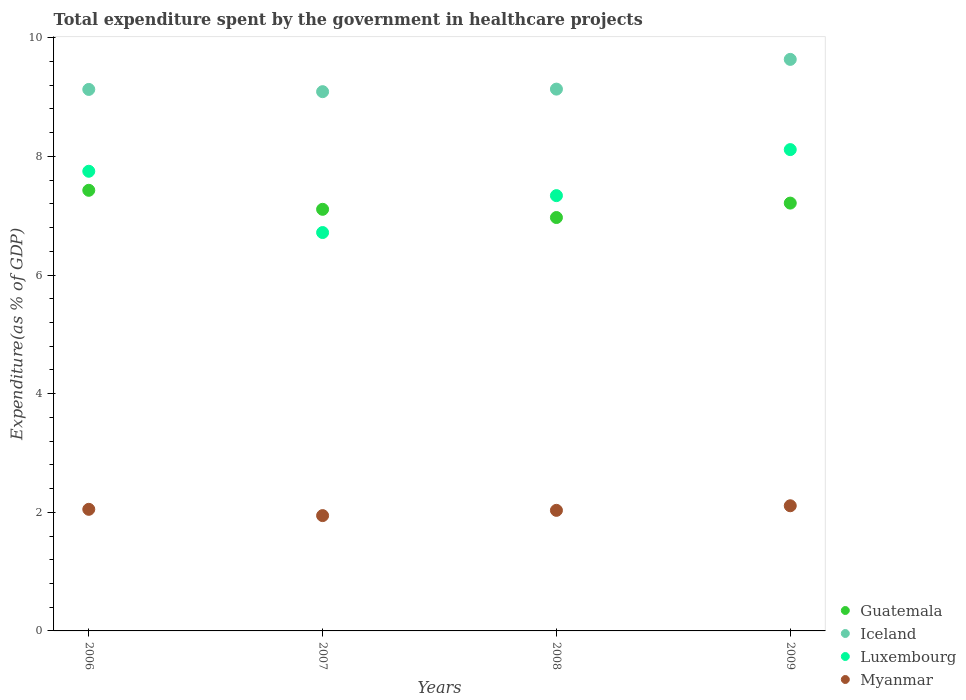Is the number of dotlines equal to the number of legend labels?
Ensure brevity in your answer.  Yes. What is the total expenditure spent by the government in healthcare projects in Iceland in 2007?
Ensure brevity in your answer.  9.09. Across all years, what is the maximum total expenditure spent by the government in healthcare projects in Guatemala?
Provide a short and direct response. 7.43. Across all years, what is the minimum total expenditure spent by the government in healthcare projects in Myanmar?
Give a very brief answer. 1.94. In which year was the total expenditure spent by the government in healthcare projects in Guatemala maximum?
Ensure brevity in your answer.  2006. What is the total total expenditure spent by the government in healthcare projects in Guatemala in the graph?
Provide a short and direct response. 28.72. What is the difference between the total expenditure spent by the government in healthcare projects in Guatemala in 2006 and that in 2008?
Provide a short and direct response. 0.46. What is the difference between the total expenditure spent by the government in healthcare projects in Iceland in 2006 and the total expenditure spent by the government in healthcare projects in Luxembourg in 2009?
Make the answer very short. 1.01. What is the average total expenditure spent by the government in healthcare projects in Iceland per year?
Offer a terse response. 9.25. In the year 2007, what is the difference between the total expenditure spent by the government in healthcare projects in Iceland and total expenditure spent by the government in healthcare projects in Luxembourg?
Offer a very short reply. 2.37. In how many years, is the total expenditure spent by the government in healthcare projects in Guatemala greater than 5.2 %?
Offer a very short reply. 4. What is the ratio of the total expenditure spent by the government in healthcare projects in Guatemala in 2007 to that in 2009?
Offer a terse response. 0.99. Is the difference between the total expenditure spent by the government in healthcare projects in Iceland in 2006 and 2009 greater than the difference between the total expenditure spent by the government in healthcare projects in Luxembourg in 2006 and 2009?
Provide a short and direct response. No. What is the difference between the highest and the second highest total expenditure spent by the government in healthcare projects in Luxembourg?
Offer a very short reply. 0.37. What is the difference between the highest and the lowest total expenditure spent by the government in healthcare projects in Myanmar?
Provide a succinct answer. 0.17. In how many years, is the total expenditure spent by the government in healthcare projects in Iceland greater than the average total expenditure spent by the government in healthcare projects in Iceland taken over all years?
Offer a terse response. 1. Is it the case that in every year, the sum of the total expenditure spent by the government in healthcare projects in Iceland and total expenditure spent by the government in healthcare projects in Guatemala  is greater than the sum of total expenditure spent by the government in healthcare projects in Luxembourg and total expenditure spent by the government in healthcare projects in Myanmar?
Give a very brief answer. Yes. Is it the case that in every year, the sum of the total expenditure spent by the government in healthcare projects in Guatemala and total expenditure spent by the government in healthcare projects in Luxembourg  is greater than the total expenditure spent by the government in healthcare projects in Myanmar?
Provide a short and direct response. Yes. Does the total expenditure spent by the government in healthcare projects in Luxembourg monotonically increase over the years?
Your answer should be very brief. No. Are the values on the major ticks of Y-axis written in scientific E-notation?
Offer a terse response. No. How many legend labels are there?
Offer a very short reply. 4. What is the title of the graph?
Provide a succinct answer. Total expenditure spent by the government in healthcare projects. What is the label or title of the X-axis?
Give a very brief answer. Years. What is the label or title of the Y-axis?
Your answer should be very brief. Expenditure(as % of GDP). What is the Expenditure(as % of GDP) of Guatemala in 2006?
Your response must be concise. 7.43. What is the Expenditure(as % of GDP) in Iceland in 2006?
Your answer should be very brief. 9.13. What is the Expenditure(as % of GDP) of Luxembourg in 2006?
Your response must be concise. 7.75. What is the Expenditure(as % of GDP) in Myanmar in 2006?
Give a very brief answer. 2.05. What is the Expenditure(as % of GDP) in Guatemala in 2007?
Keep it short and to the point. 7.11. What is the Expenditure(as % of GDP) in Iceland in 2007?
Offer a terse response. 9.09. What is the Expenditure(as % of GDP) of Luxembourg in 2007?
Make the answer very short. 6.72. What is the Expenditure(as % of GDP) of Myanmar in 2007?
Give a very brief answer. 1.94. What is the Expenditure(as % of GDP) in Guatemala in 2008?
Keep it short and to the point. 6.97. What is the Expenditure(as % of GDP) of Iceland in 2008?
Your answer should be compact. 9.13. What is the Expenditure(as % of GDP) of Luxembourg in 2008?
Give a very brief answer. 7.34. What is the Expenditure(as % of GDP) in Myanmar in 2008?
Keep it short and to the point. 2.03. What is the Expenditure(as % of GDP) in Guatemala in 2009?
Your answer should be very brief. 7.21. What is the Expenditure(as % of GDP) in Iceland in 2009?
Provide a succinct answer. 9.64. What is the Expenditure(as % of GDP) of Luxembourg in 2009?
Provide a short and direct response. 8.11. What is the Expenditure(as % of GDP) of Myanmar in 2009?
Provide a short and direct response. 2.11. Across all years, what is the maximum Expenditure(as % of GDP) in Guatemala?
Your answer should be very brief. 7.43. Across all years, what is the maximum Expenditure(as % of GDP) of Iceland?
Offer a terse response. 9.64. Across all years, what is the maximum Expenditure(as % of GDP) of Luxembourg?
Offer a very short reply. 8.11. Across all years, what is the maximum Expenditure(as % of GDP) of Myanmar?
Your response must be concise. 2.11. Across all years, what is the minimum Expenditure(as % of GDP) of Guatemala?
Offer a very short reply. 6.97. Across all years, what is the minimum Expenditure(as % of GDP) of Iceland?
Your response must be concise. 9.09. Across all years, what is the minimum Expenditure(as % of GDP) in Luxembourg?
Ensure brevity in your answer.  6.72. Across all years, what is the minimum Expenditure(as % of GDP) of Myanmar?
Your response must be concise. 1.94. What is the total Expenditure(as % of GDP) in Guatemala in the graph?
Your answer should be very brief. 28.72. What is the total Expenditure(as % of GDP) in Iceland in the graph?
Provide a succinct answer. 36.99. What is the total Expenditure(as % of GDP) of Luxembourg in the graph?
Offer a very short reply. 29.92. What is the total Expenditure(as % of GDP) of Myanmar in the graph?
Offer a very short reply. 8.14. What is the difference between the Expenditure(as % of GDP) in Guatemala in 2006 and that in 2007?
Ensure brevity in your answer.  0.32. What is the difference between the Expenditure(as % of GDP) of Iceland in 2006 and that in 2007?
Give a very brief answer. 0.04. What is the difference between the Expenditure(as % of GDP) in Luxembourg in 2006 and that in 2007?
Offer a terse response. 1.03. What is the difference between the Expenditure(as % of GDP) of Myanmar in 2006 and that in 2007?
Provide a succinct answer. 0.11. What is the difference between the Expenditure(as % of GDP) of Guatemala in 2006 and that in 2008?
Ensure brevity in your answer.  0.46. What is the difference between the Expenditure(as % of GDP) of Iceland in 2006 and that in 2008?
Ensure brevity in your answer.  -0.01. What is the difference between the Expenditure(as % of GDP) of Luxembourg in 2006 and that in 2008?
Your answer should be compact. 0.41. What is the difference between the Expenditure(as % of GDP) of Myanmar in 2006 and that in 2008?
Ensure brevity in your answer.  0.02. What is the difference between the Expenditure(as % of GDP) of Guatemala in 2006 and that in 2009?
Offer a terse response. 0.22. What is the difference between the Expenditure(as % of GDP) of Iceland in 2006 and that in 2009?
Your response must be concise. -0.51. What is the difference between the Expenditure(as % of GDP) in Luxembourg in 2006 and that in 2009?
Provide a succinct answer. -0.37. What is the difference between the Expenditure(as % of GDP) of Myanmar in 2006 and that in 2009?
Your response must be concise. -0.06. What is the difference between the Expenditure(as % of GDP) in Guatemala in 2007 and that in 2008?
Ensure brevity in your answer.  0.14. What is the difference between the Expenditure(as % of GDP) in Iceland in 2007 and that in 2008?
Give a very brief answer. -0.04. What is the difference between the Expenditure(as % of GDP) of Luxembourg in 2007 and that in 2008?
Keep it short and to the point. -0.62. What is the difference between the Expenditure(as % of GDP) in Myanmar in 2007 and that in 2008?
Provide a short and direct response. -0.09. What is the difference between the Expenditure(as % of GDP) in Guatemala in 2007 and that in 2009?
Make the answer very short. -0.1. What is the difference between the Expenditure(as % of GDP) in Iceland in 2007 and that in 2009?
Provide a succinct answer. -0.54. What is the difference between the Expenditure(as % of GDP) of Luxembourg in 2007 and that in 2009?
Your response must be concise. -1.4. What is the difference between the Expenditure(as % of GDP) in Myanmar in 2007 and that in 2009?
Your answer should be very brief. -0.17. What is the difference between the Expenditure(as % of GDP) of Guatemala in 2008 and that in 2009?
Give a very brief answer. -0.24. What is the difference between the Expenditure(as % of GDP) in Iceland in 2008 and that in 2009?
Your answer should be very brief. -0.5. What is the difference between the Expenditure(as % of GDP) of Luxembourg in 2008 and that in 2009?
Offer a terse response. -0.78. What is the difference between the Expenditure(as % of GDP) of Myanmar in 2008 and that in 2009?
Offer a very short reply. -0.08. What is the difference between the Expenditure(as % of GDP) in Guatemala in 2006 and the Expenditure(as % of GDP) in Iceland in 2007?
Provide a short and direct response. -1.66. What is the difference between the Expenditure(as % of GDP) in Guatemala in 2006 and the Expenditure(as % of GDP) in Luxembourg in 2007?
Your answer should be very brief. 0.71. What is the difference between the Expenditure(as % of GDP) of Guatemala in 2006 and the Expenditure(as % of GDP) of Myanmar in 2007?
Make the answer very short. 5.48. What is the difference between the Expenditure(as % of GDP) in Iceland in 2006 and the Expenditure(as % of GDP) in Luxembourg in 2007?
Provide a succinct answer. 2.41. What is the difference between the Expenditure(as % of GDP) in Iceland in 2006 and the Expenditure(as % of GDP) in Myanmar in 2007?
Offer a very short reply. 7.19. What is the difference between the Expenditure(as % of GDP) of Luxembourg in 2006 and the Expenditure(as % of GDP) of Myanmar in 2007?
Your answer should be very brief. 5.81. What is the difference between the Expenditure(as % of GDP) of Guatemala in 2006 and the Expenditure(as % of GDP) of Iceland in 2008?
Offer a terse response. -1.71. What is the difference between the Expenditure(as % of GDP) of Guatemala in 2006 and the Expenditure(as % of GDP) of Luxembourg in 2008?
Your answer should be compact. 0.09. What is the difference between the Expenditure(as % of GDP) in Guatemala in 2006 and the Expenditure(as % of GDP) in Myanmar in 2008?
Make the answer very short. 5.4. What is the difference between the Expenditure(as % of GDP) in Iceland in 2006 and the Expenditure(as % of GDP) in Luxembourg in 2008?
Your answer should be very brief. 1.79. What is the difference between the Expenditure(as % of GDP) in Iceland in 2006 and the Expenditure(as % of GDP) in Myanmar in 2008?
Your response must be concise. 7.1. What is the difference between the Expenditure(as % of GDP) in Luxembourg in 2006 and the Expenditure(as % of GDP) in Myanmar in 2008?
Your answer should be compact. 5.72. What is the difference between the Expenditure(as % of GDP) of Guatemala in 2006 and the Expenditure(as % of GDP) of Iceland in 2009?
Keep it short and to the point. -2.21. What is the difference between the Expenditure(as % of GDP) in Guatemala in 2006 and the Expenditure(as % of GDP) in Luxembourg in 2009?
Your answer should be very brief. -0.69. What is the difference between the Expenditure(as % of GDP) in Guatemala in 2006 and the Expenditure(as % of GDP) in Myanmar in 2009?
Give a very brief answer. 5.32. What is the difference between the Expenditure(as % of GDP) in Iceland in 2006 and the Expenditure(as % of GDP) in Luxembourg in 2009?
Provide a succinct answer. 1.01. What is the difference between the Expenditure(as % of GDP) in Iceland in 2006 and the Expenditure(as % of GDP) in Myanmar in 2009?
Offer a terse response. 7.02. What is the difference between the Expenditure(as % of GDP) of Luxembourg in 2006 and the Expenditure(as % of GDP) of Myanmar in 2009?
Make the answer very short. 5.64. What is the difference between the Expenditure(as % of GDP) of Guatemala in 2007 and the Expenditure(as % of GDP) of Iceland in 2008?
Offer a terse response. -2.03. What is the difference between the Expenditure(as % of GDP) of Guatemala in 2007 and the Expenditure(as % of GDP) of Luxembourg in 2008?
Your response must be concise. -0.23. What is the difference between the Expenditure(as % of GDP) of Guatemala in 2007 and the Expenditure(as % of GDP) of Myanmar in 2008?
Your response must be concise. 5.08. What is the difference between the Expenditure(as % of GDP) of Iceland in 2007 and the Expenditure(as % of GDP) of Luxembourg in 2008?
Your response must be concise. 1.75. What is the difference between the Expenditure(as % of GDP) in Iceland in 2007 and the Expenditure(as % of GDP) in Myanmar in 2008?
Your response must be concise. 7.06. What is the difference between the Expenditure(as % of GDP) in Luxembourg in 2007 and the Expenditure(as % of GDP) in Myanmar in 2008?
Provide a short and direct response. 4.68. What is the difference between the Expenditure(as % of GDP) in Guatemala in 2007 and the Expenditure(as % of GDP) in Iceland in 2009?
Provide a succinct answer. -2.53. What is the difference between the Expenditure(as % of GDP) in Guatemala in 2007 and the Expenditure(as % of GDP) in Luxembourg in 2009?
Your answer should be compact. -1.01. What is the difference between the Expenditure(as % of GDP) in Guatemala in 2007 and the Expenditure(as % of GDP) in Myanmar in 2009?
Give a very brief answer. 5. What is the difference between the Expenditure(as % of GDP) of Iceland in 2007 and the Expenditure(as % of GDP) of Luxembourg in 2009?
Provide a succinct answer. 0.98. What is the difference between the Expenditure(as % of GDP) in Iceland in 2007 and the Expenditure(as % of GDP) in Myanmar in 2009?
Give a very brief answer. 6.98. What is the difference between the Expenditure(as % of GDP) in Luxembourg in 2007 and the Expenditure(as % of GDP) in Myanmar in 2009?
Ensure brevity in your answer.  4.61. What is the difference between the Expenditure(as % of GDP) in Guatemala in 2008 and the Expenditure(as % of GDP) in Iceland in 2009?
Provide a succinct answer. -2.67. What is the difference between the Expenditure(as % of GDP) of Guatemala in 2008 and the Expenditure(as % of GDP) of Luxembourg in 2009?
Offer a terse response. -1.15. What is the difference between the Expenditure(as % of GDP) in Guatemala in 2008 and the Expenditure(as % of GDP) in Myanmar in 2009?
Provide a succinct answer. 4.86. What is the difference between the Expenditure(as % of GDP) of Iceland in 2008 and the Expenditure(as % of GDP) of Luxembourg in 2009?
Ensure brevity in your answer.  1.02. What is the difference between the Expenditure(as % of GDP) in Iceland in 2008 and the Expenditure(as % of GDP) in Myanmar in 2009?
Offer a terse response. 7.02. What is the difference between the Expenditure(as % of GDP) in Luxembourg in 2008 and the Expenditure(as % of GDP) in Myanmar in 2009?
Provide a succinct answer. 5.23. What is the average Expenditure(as % of GDP) in Guatemala per year?
Your answer should be very brief. 7.18. What is the average Expenditure(as % of GDP) of Iceland per year?
Ensure brevity in your answer.  9.25. What is the average Expenditure(as % of GDP) in Luxembourg per year?
Offer a very short reply. 7.48. What is the average Expenditure(as % of GDP) in Myanmar per year?
Your response must be concise. 2.03. In the year 2006, what is the difference between the Expenditure(as % of GDP) of Guatemala and Expenditure(as % of GDP) of Iceland?
Provide a short and direct response. -1.7. In the year 2006, what is the difference between the Expenditure(as % of GDP) in Guatemala and Expenditure(as % of GDP) in Luxembourg?
Ensure brevity in your answer.  -0.32. In the year 2006, what is the difference between the Expenditure(as % of GDP) of Guatemala and Expenditure(as % of GDP) of Myanmar?
Offer a terse response. 5.38. In the year 2006, what is the difference between the Expenditure(as % of GDP) of Iceland and Expenditure(as % of GDP) of Luxembourg?
Make the answer very short. 1.38. In the year 2006, what is the difference between the Expenditure(as % of GDP) of Iceland and Expenditure(as % of GDP) of Myanmar?
Make the answer very short. 7.08. In the year 2006, what is the difference between the Expenditure(as % of GDP) of Luxembourg and Expenditure(as % of GDP) of Myanmar?
Ensure brevity in your answer.  5.7. In the year 2007, what is the difference between the Expenditure(as % of GDP) of Guatemala and Expenditure(as % of GDP) of Iceland?
Keep it short and to the point. -1.98. In the year 2007, what is the difference between the Expenditure(as % of GDP) in Guatemala and Expenditure(as % of GDP) in Luxembourg?
Offer a terse response. 0.39. In the year 2007, what is the difference between the Expenditure(as % of GDP) of Guatemala and Expenditure(as % of GDP) of Myanmar?
Your answer should be very brief. 5.16. In the year 2007, what is the difference between the Expenditure(as % of GDP) of Iceland and Expenditure(as % of GDP) of Luxembourg?
Your response must be concise. 2.38. In the year 2007, what is the difference between the Expenditure(as % of GDP) of Iceland and Expenditure(as % of GDP) of Myanmar?
Make the answer very short. 7.15. In the year 2007, what is the difference between the Expenditure(as % of GDP) in Luxembourg and Expenditure(as % of GDP) in Myanmar?
Provide a succinct answer. 4.77. In the year 2008, what is the difference between the Expenditure(as % of GDP) in Guatemala and Expenditure(as % of GDP) in Iceland?
Give a very brief answer. -2.17. In the year 2008, what is the difference between the Expenditure(as % of GDP) in Guatemala and Expenditure(as % of GDP) in Luxembourg?
Offer a terse response. -0.37. In the year 2008, what is the difference between the Expenditure(as % of GDP) of Guatemala and Expenditure(as % of GDP) of Myanmar?
Your answer should be compact. 4.94. In the year 2008, what is the difference between the Expenditure(as % of GDP) in Iceland and Expenditure(as % of GDP) in Luxembourg?
Provide a short and direct response. 1.8. In the year 2008, what is the difference between the Expenditure(as % of GDP) of Iceland and Expenditure(as % of GDP) of Myanmar?
Make the answer very short. 7.1. In the year 2008, what is the difference between the Expenditure(as % of GDP) in Luxembourg and Expenditure(as % of GDP) in Myanmar?
Your response must be concise. 5.31. In the year 2009, what is the difference between the Expenditure(as % of GDP) in Guatemala and Expenditure(as % of GDP) in Iceland?
Provide a succinct answer. -2.42. In the year 2009, what is the difference between the Expenditure(as % of GDP) in Guatemala and Expenditure(as % of GDP) in Luxembourg?
Offer a terse response. -0.9. In the year 2009, what is the difference between the Expenditure(as % of GDP) in Guatemala and Expenditure(as % of GDP) in Myanmar?
Give a very brief answer. 5.1. In the year 2009, what is the difference between the Expenditure(as % of GDP) in Iceland and Expenditure(as % of GDP) in Luxembourg?
Give a very brief answer. 1.52. In the year 2009, what is the difference between the Expenditure(as % of GDP) of Iceland and Expenditure(as % of GDP) of Myanmar?
Keep it short and to the point. 7.53. In the year 2009, what is the difference between the Expenditure(as % of GDP) of Luxembourg and Expenditure(as % of GDP) of Myanmar?
Provide a short and direct response. 6. What is the ratio of the Expenditure(as % of GDP) of Guatemala in 2006 to that in 2007?
Ensure brevity in your answer.  1.05. What is the ratio of the Expenditure(as % of GDP) of Luxembourg in 2006 to that in 2007?
Give a very brief answer. 1.15. What is the ratio of the Expenditure(as % of GDP) in Myanmar in 2006 to that in 2007?
Keep it short and to the point. 1.05. What is the ratio of the Expenditure(as % of GDP) in Guatemala in 2006 to that in 2008?
Make the answer very short. 1.07. What is the ratio of the Expenditure(as % of GDP) in Luxembourg in 2006 to that in 2008?
Your answer should be compact. 1.06. What is the ratio of the Expenditure(as % of GDP) of Myanmar in 2006 to that in 2008?
Your response must be concise. 1.01. What is the ratio of the Expenditure(as % of GDP) in Guatemala in 2006 to that in 2009?
Give a very brief answer. 1.03. What is the ratio of the Expenditure(as % of GDP) in Iceland in 2006 to that in 2009?
Offer a terse response. 0.95. What is the ratio of the Expenditure(as % of GDP) in Luxembourg in 2006 to that in 2009?
Give a very brief answer. 0.95. What is the ratio of the Expenditure(as % of GDP) in Myanmar in 2006 to that in 2009?
Provide a succinct answer. 0.97. What is the ratio of the Expenditure(as % of GDP) in Guatemala in 2007 to that in 2008?
Give a very brief answer. 1.02. What is the ratio of the Expenditure(as % of GDP) of Iceland in 2007 to that in 2008?
Provide a short and direct response. 1. What is the ratio of the Expenditure(as % of GDP) in Luxembourg in 2007 to that in 2008?
Your answer should be very brief. 0.92. What is the ratio of the Expenditure(as % of GDP) in Myanmar in 2007 to that in 2008?
Provide a short and direct response. 0.96. What is the ratio of the Expenditure(as % of GDP) of Guatemala in 2007 to that in 2009?
Provide a short and direct response. 0.99. What is the ratio of the Expenditure(as % of GDP) in Iceland in 2007 to that in 2009?
Provide a succinct answer. 0.94. What is the ratio of the Expenditure(as % of GDP) in Luxembourg in 2007 to that in 2009?
Keep it short and to the point. 0.83. What is the ratio of the Expenditure(as % of GDP) in Myanmar in 2007 to that in 2009?
Offer a terse response. 0.92. What is the ratio of the Expenditure(as % of GDP) of Guatemala in 2008 to that in 2009?
Keep it short and to the point. 0.97. What is the ratio of the Expenditure(as % of GDP) of Iceland in 2008 to that in 2009?
Keep it short and to the point. 0.95. What is the ratio of the Expenditure(as % of GDP) in Luxembourg in 2008 to that in 2009?
Your answer should be compact. 0.9. What is the ratio of the Expenditure(as % of GDP) in Myanmar in 2008 to that in 2009?
Offer a very short reply. 0.96. What is the difference between the highest and the second highest Expenditure(as % of GDP) in Guatemala?
Make the answer very short. 0.22. What is the difference between the highest and the second highest Expenditure(as % of GDP) of Iceland?
Offer a terse response. 0.5. What is the difference between the highest and the second highest Expenditure(as % of GDP) in Luxembourg?
Provide a succinct answer. 0.37. What is the difference between the highest and the second highest Expenditure(as % of GDP) of Myanmar?
Provide a succinct answer. 0.06. What is the difference between the highest and the lowest Expenditure(as % of GDP) of Guatemala?
Offer a terse response. 0.46. What is the difference between the highest and the lowest Expenditure(as % of GDP) in Iceland?
Provide a short and direct response. 0.54. What is the difference between the highest and the lowest Expenditure(as % of GDP) of Luxembourg?
Provide a succinct answer. 1.4. What is the difference between the highest and the lowest Expenditure(as % of GDP) in Myanmar?
Keep it short and to the point. 0.17. 